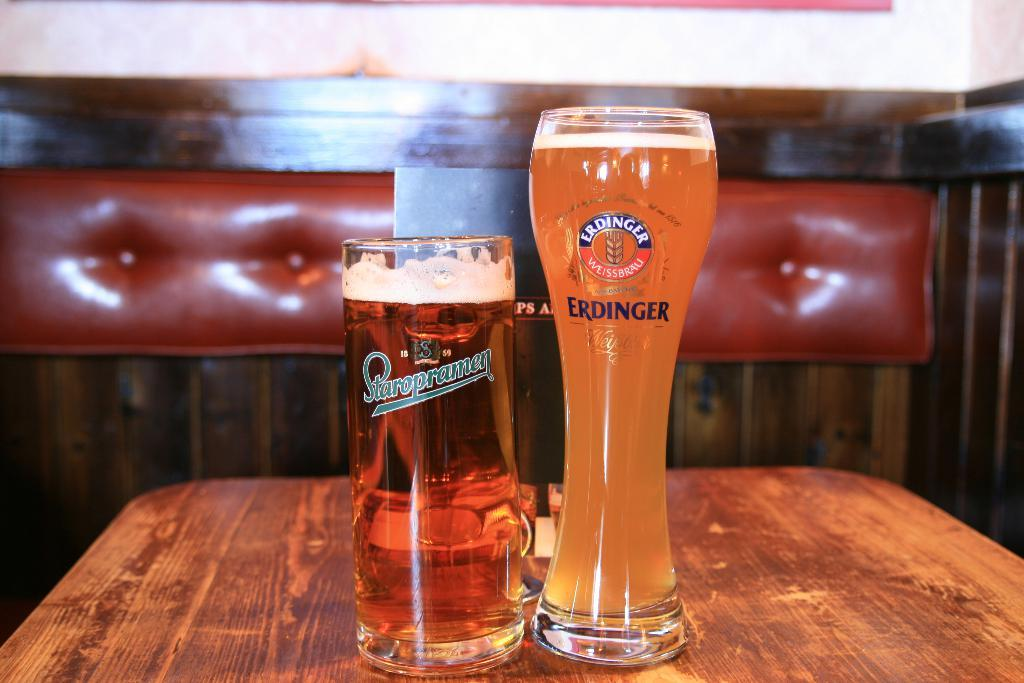<image>
Give a short and clear explanation of the subsequent image. Two glasses full with beer the one on the right is taller but thinner, one from the Erdinger brand and the other Staropramen brand. 